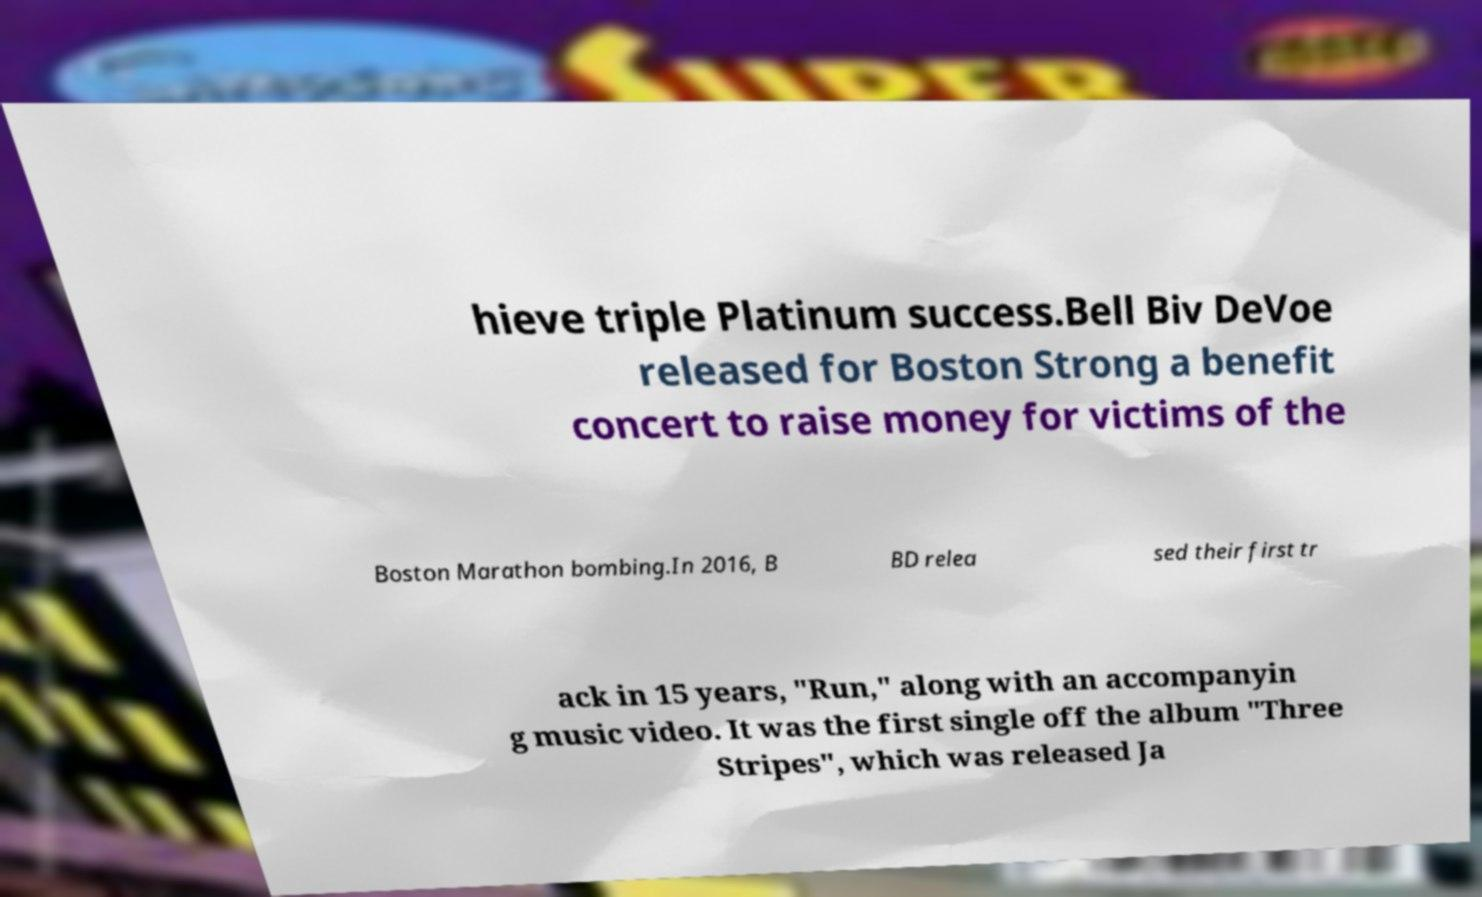Please read and relay the text visible in this image. What does it say? hieve triple Platinum success.Bell Biv DeVoe released for Boston Strong a benefit concert to raise money for victims of the Boston Marathon bombing.In 2016, B BD relea sed their first tr ack in 15 years, "Run," along with an accompanyin g music video. It was the first single off the album "Three Stripes", which was released Ja 